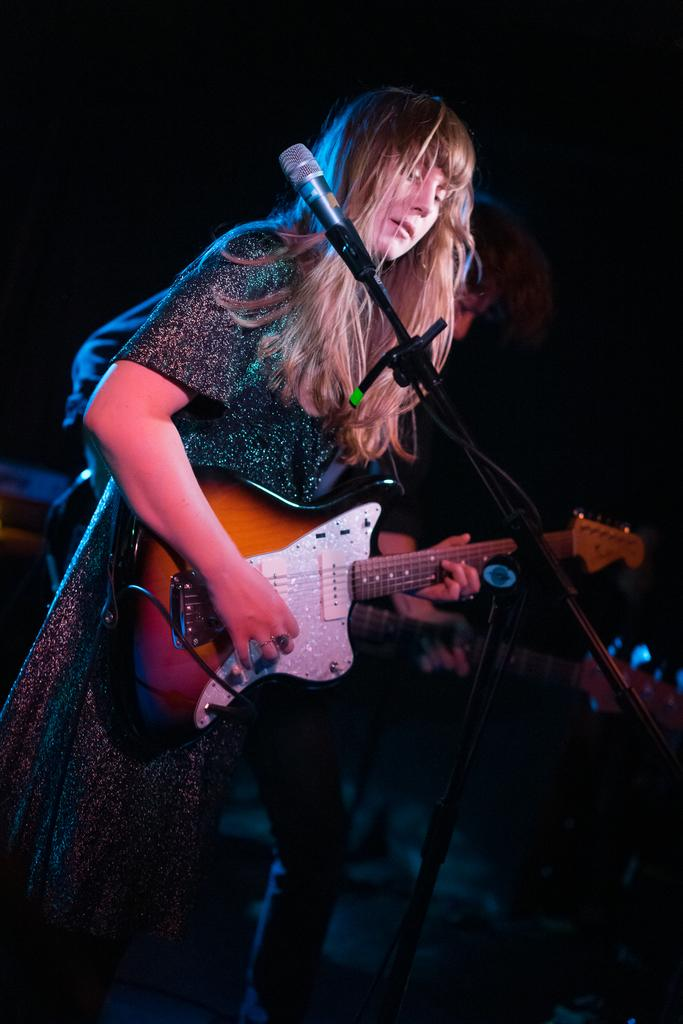What is the overall color scheme of the image? The background of the image is dark. Who is the main subject in the image? There is a woman in the image. What is the woman doing in the image? The woman is standing in front of a microphone and playing guitar. Are there any other people in the image? Yes, there is another person in the image. What is the other person doing in the image? The other person is also playing guitar. Can you see a ship in the image? No, there is no ship present in the image. What type of doll is the woman holding while playing guitar? There is no doll visible in the image; the woman is playing guitar without any additional objects. 